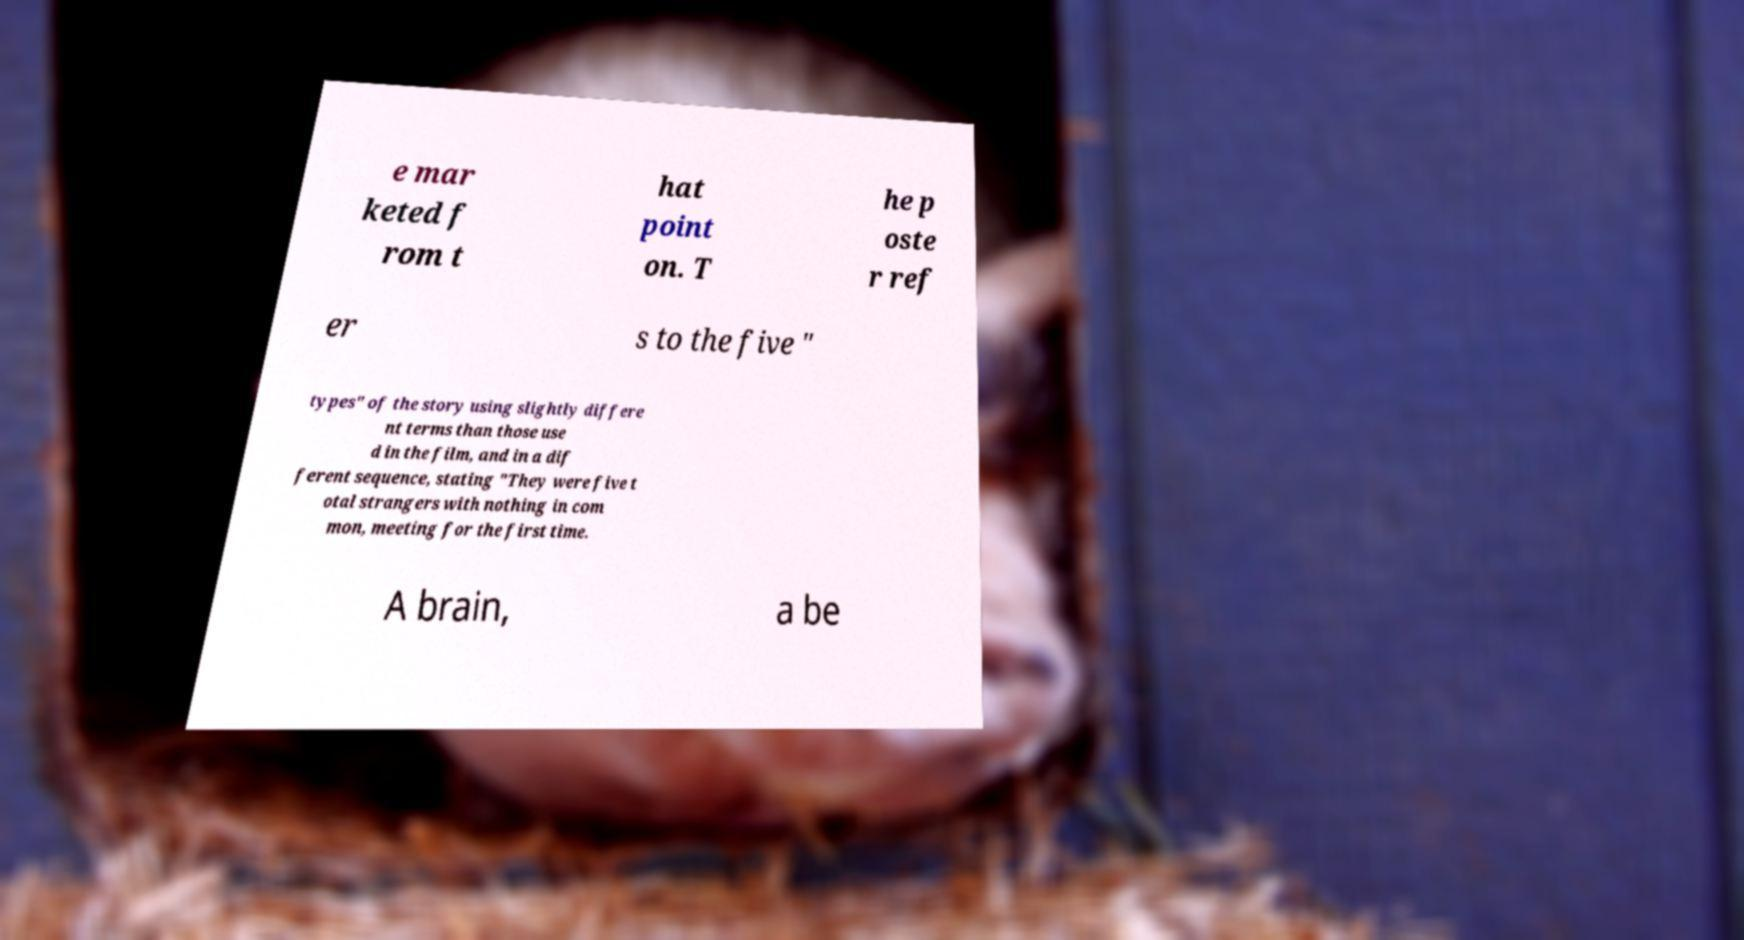What messages or text are displayed in this image? I need them in a readable, typed format. e mar keted f rom t hat point on. T he p oste r ref er s to the five " types" of the story using slightly differe nt terms than those use d in the film, and in a dif ferent sequence, stating "They were five t otal strangers with nothing in com mon, meeting for the first time. A brain, a be 